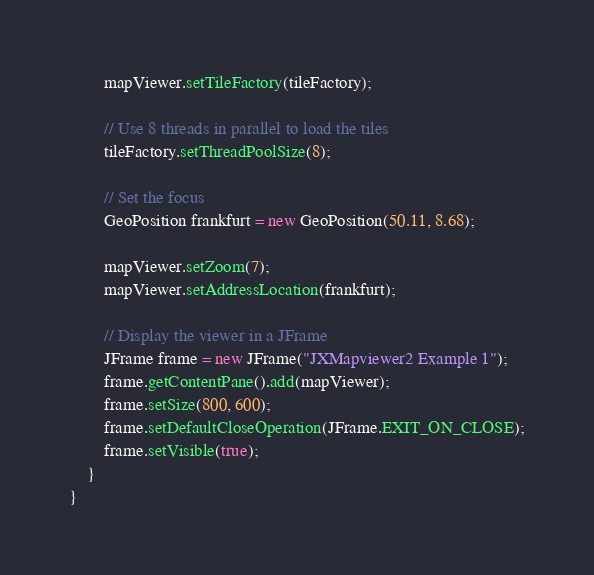<code> <loc_0><loc_0><loc_500><loc_500><_Java_>		mapViewer.setTileFactory(tileFactory);
		
		// Use 8 threads in parallel to load the tiles
		tileFactory.setThreadPoolSize(8);

		// Set the focus
		GeoPosition frankfurt = new GeoPosition(50.11, 8.68);

		mapViewer.setZoom(7);
		mapViewer.setAddressLocation(frankfurt);
		
		// Display the viewer in a JFrame
		JFrame frame = new JFrame("JXMapviewer2 Example 1");
		frame.getContentPane().add(mapViewer);
		frame.setSize(800, 600);
		frame.setDefaultCloseOperation(JFrame.EXIT_ON_CLOSE);
		frame.setVisible(true);
	}
}
</code> 